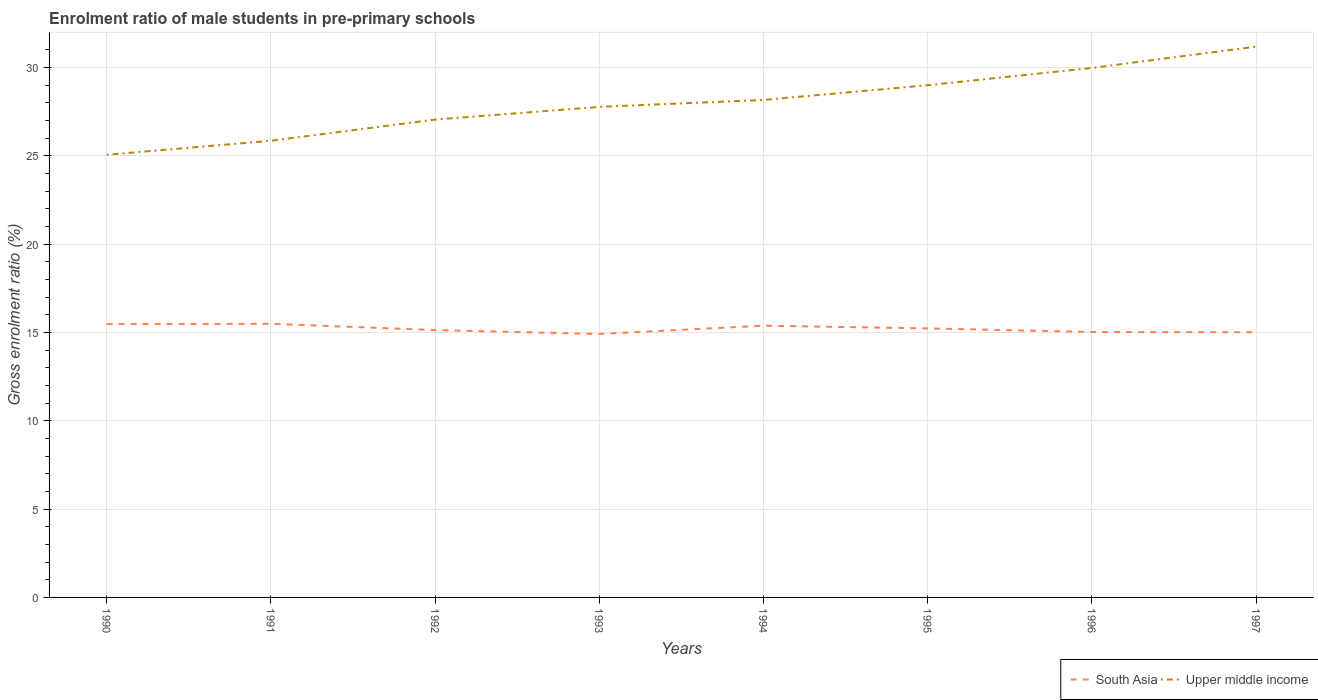How many different coloured lines are there?
Offer a very short reply. 2. Is the number of lines equal to the number of legend labels?
Keep it short and to the point. Yes. Across all years, what is the maximum enrolment ratio of male students in pre-primary schools in South Asia?
Offer a terse response. 14.91. What is the total enrolment ratio of male students in pre-primary schools in South Asia in the graph?
Provide a short and direct response. -0.11. What is the difference between the highest and the second highest enrolment ratio of male students in pre-primary schools in Upper middle income?
Provide a succinct answer. 6.12. How many lines are there?
Offer a terse response. 2. How many years are there in the graph?
Make the answer very short. 8. Does the graph contain any zero values?
Keep it short and to the point. No. Does the graph contain grids?
Keep it short and to the point. Yes. Where does the legend appear in the graph?
Give a very brief answer. Bottom right. How are the legend labels stacked?
Ensure brevity in your answer.  Horizontal. What is the title of the graph?
Make the answer very short. Enrolment ratio of male students in pre-primary schools. Does "Austria" appear as one of the legend labels in the graph?
Your response must be concise. No. What is the label or title of the X-axis?
Provide a short and direct response. Years. What is the Gross enrolment ratio (%) in South Asia in 1990?
Give a very brief answer. 15.47. What is the Gross enrolment ratio (%) in Upper middle income in 1990?
Your response must be concise. 25.06. What is the Gross enrolment ratio (%) of South Asia in 1991?
Your answer should be very brief. 15.49. What is the Gross enrolment ratio (%) in Upper middle income in 1991?
Offer a very short reply. 25.85. What is the Gross enrolment ratio (%) in South Asia in 1992?
Provide a short and direct response. 15.13. What is the Gross enrolment ratio (%) in Upper middle income in 1992?
Offer a very short reply. 27.05. What is the Gross enrolment ratio (%) in South Asia in 1993?
Make the answer very short. 14.91. What is the Gross enrolment ratio (%) in Upper middle income in 1993?
Give a very brief answer. 27.77. What is the Gross enrolment ratio (%) of South Asia in 1994?
Give a very brief answer. 15.38. What is the Gross enrolment ratio (%) of Upper middle income in 1994?
Offer a very short reply. 28.16. What is the Gross enrolment ratio (%) of South Asia in 1995?
Provide a succinct answer. 15.23. What is the Gross enrolment ratio (%) in Upper middle income in 1995?
Your answer should be very brief. 29. What is the Gross enrolment ratio (%) in South Asia in 1996?
Ensure brevity in your answer.  15.03. What is the Gross enrolment ratio (%) in Upper middle income in 1996?
Your answer should be very brief. 29.97. What is the Gross enrolment ratio (%) in South Asia in 1997?
Give a very brief answer. 15.01. What is the Gross enrolment ratio (%) of Upper middle income in 1997?
Offer a very short reply. 31.18. Across all years, what is the maximum Gross enrolment ratio (%) of South Asia?
Your answer should be compact. 15.49. Across all years, what is the maximum Gross enrolment ratio (%) in Upper middle income?
Make the answer very short. 31.18. Across all years, what is the minimum Gross enrolment ratio (%) of South Asia?
Your answer should be compact. 14.91. Across all years, what is the minimum Gross enrolment ratio (%) in Upper middle income?
Provide a succinct answer. 25.06. What is the total Gross enrolment ratio (%) in South Asia in the graph?
Offer a very short reply. 121.66. What is the total Gross enrolment ratio (%) in Upper middle income in the graph?
Offer a terse response. 224.05. What is the difference between the Gross enrolment ratio (%) of South Asia in 1990 and that in 1991?
Give a very brief answer. -0.02. What is the difference between the Gross enrolment ratio (%) of Upper middle income in 1990 and that in 1991?
Provide a succinct answer. -0.79. What is the difference between the Gross enrolment ratio (%) in South Asia in 1990 and that in 1992?
Your answer should be very brief. 0.34. What is the difference between the Gross enrolment ratio (%) of Upper middle income in 1990 and that in 1992?
Give a very brief answer. -1.99. What is the difference between the Gross enrolment ratio (%) of South Asia in 1990 and that in 1993?
Keep it short and to the point. 0.56. What is the difference between the Gross enrolment ratio (%) of Upper middle income in 1990 and that in 1993?
Your answer should be very brief. -2.71. What is the difference between the Gross enrolment ratio (%) in South Asia in 1990 and that in 1994?
Ensure brevity in your answer.  0.09. What is the difference between the Gross enrolment ratio (%) in Upper middle income in 1990 and that in 1994?
Provide a succinct answer. -3.1. What is the difference between the Gross enrolment ratio (%) of South Asia in 1990 and that in 1995?
Your answer should be compact. 0.24. What is the difference between the Gross enrolment ratio (%) in Upper middle income in 1990 and that in 1995?
Give a very brief answer. -3.94. What is the difference between the Gross enrolment ratio (%) in South Asia in 1990 and that in 1996?
Provide a succinct answer. 0.45. What is the difference between the Gross enrolment ratio (%) in Upper middle income in 1990 and that in 1996?
Offer a very short reply. -4.92. What is the difference between the Gross enrolment ratio (%) of South Asia in 1990 and that in 1997?
Give a very brief answer. 0.46. What is the difference between the Gross enrolment ratio (%) in Upper middle income in 1990 and that in 1997?
Give a very brief answer. -6.12. What is the difference between the Gross enrolment ratio (%) in South Asia in 1991 and that in 1992?
Provide a short and direct response. 0.36. What is the difference between the Gross enrolment ratio (%) in Upper middle income in 1991 and that in 1992?
Your answer should be very brief. -1.2. What is the difference between the Gross enrolment ratio (%) in South Asia in 1991 and that in 1993?
Keep it short and to the point. 0.58. What is the difference between the Gross enrolment ratio (%) in Upper middle income in 1991 and that in 1993?
Make the answer very short. -1.92. What is the difference between the Gross enrolment ratio (%) in South Asia in 1991 and that in 1994?
Provide a short and direct response. 0.11. What is the difference between the Gross enrolment ratio (%) of Upper middle income in 1991 and that in 1994?
Make the answer very short. -2.31. What is the difference between the Gross enrolment ratio (%) of South Asia in 1991 and that in 1995?
Your answer should be compact. 0.26. What is the difference between the Gross enrolment ratio (%) in Upper middle income in 1991 and that in 1995?
Provide a short and direct response. -3.15. What is the difference between the Gross enrolment ratio (%) of South Asia in 1991 and that in 1996?
Your answer should be compact. 0.47. What is the difference between the Gross enrolment ratio (%) of Upper middle income in 1991 and that in 1996?
Give a very brief answer. -4.12. What is the difference between the Gross enrolment ratio (%) of South Asia in 1991 and that in 1997?
Your response must be concise. 0.48. What is the difference between the Gross enrolment ratio (%) of Upper middle income in 1991 and that in 1997?
Keep it short and to the point. -5.33. What is the difference between the Gross enrolment ratio (%) of South Asia in 1992 and that in 1993?
Provide a succinct answer. 0.22. What is the difference between the Gross enrolment ratio (%) in Upper middle income in 1992 and that in 1993?
Give a very brief answer. -0.72. What is the difference between the Gross enrolment ratio (%) of South Asia in 1992 and that in 1994?
Offer a terse response. -0.25. What is the difference between the Gross enrolment ratio (%) of Upper middle income in 1992 and that in 1994?
Provide a succinct answer. -1.11. What is the difference between the Gross enrolment ratio (%) in South Asia in 1992 and that in 1995?
Make the answer very short. -0.09. What is the difference between the Gross enrolment ratio (%) of Upper middle income in 1992 and that in 1995?
Make the answer very short. -1.95. What is the difference between the Gross enrolment ratio (%) in South Asia in 1992 and that in 1996?
Provide a succinct answer. 0.11. What is the difference between the Gross enrolment ratio (%) in Upper middle income in 1992 and that in 1996?
Ensure brevity in your answer.  -2.92. What is the difference between the Gross enrolment ratio (%) in South Asia in 1992 and that in 1997?
Give a very brief answer. 0.12. What is the difference between the Gross enrolment ratio (%) in Upper middle income in 1992 and that in 1997?
Your response must be concise. -4.13. What is the difference between the Gross enrolment ratio (%) of South Asia in 1993 and that in 1994?
Your answer should be very brief. -0.47. What is the difference between the Gross enrolment ratio (%) of Upper middle income in 1993 and that in 1994?
Keep it short and to the point. -0.39. What is the difference between the Gross enrolment ratio (%) of South Asia in 1993 and that in 1995?
Your answer should be very brief. -0.32. What is the difference between the Gross enrolment ratio (%) in Upper middle income in 1993 and that in 1995?
Your answer should be compact. -1.23. What is the difference between the Gross enrolment ratio (%) in South Asia in 1993 and that in 1996?
Keep it short and to the point. -0.11. What is the difference between the Gross enrolment ratio (%) of Upper middle income in 1993 and that in 1996?
Your answer should be very brief. -2.2. What is the difference between the Gross enrolment ratio (%) in South Asia in 1993 and that in 1997?
Provide a succinct answer. -0.1. What is the difference between the Gross enrolment ratio (%) of Upper middle income in 1993 and that in 1997?
Offer a terse response. -3.41. What is the difference between the Gross enrolment ratio (%) of South Asia in 1994 and that in 1995?
Provide a short and direct response. 0.15. What is the difference between the Gross enrolment ratio (%) in Upper middle income in 1994 and that in 1995?
Provide a succinct answer. -0.83. What is the difference between the Gross enrolment ratio (%) in South Asia in 1994 and that in 1996?
Make the answer very short. 0.36. What is the difference between the Gross enrolment ratio (%) in Upper middle income in 1994 and that in 1996?
Your answer should be very brief. -1.81. What is the difference between the Gross enrolment ratio (%) of South Asia in 1994 and that in 1997?
Ensure brevity in your answer.  0.37. What is the difference between the Gross enrolment ratio (%) in Upper middle income in 1994 and that in 1997?
Provide a succinct answer. -3.02. What is the difference between the Gross enrolment ratio (%) in South Asia in 1995 and that in 1996?
Your response must be concise. 0.2. What is the difference between the Gross enrolment ratio (%) in Upper middle income in 1995 and that in 1996?
Your response must be concise. -0.98. What is the difference between the Gross enrolment ratio (%) in South Asia in 1995 and that in 1997?
Offer a very short reply. 0.22. What is the difference between the Gross enrolment ratio (%) in Upper middle income in 1995 and that in 1997?
Ensure brevity in your answer.  -2.18. What is the difference between the Gross enrolment ratio (%) of South Asia in 1996 and that in 1997?
Give a very brief answer. 0.01. What is the difference between the Gross enrolment ratio (%) of Upper middle income in 1996 and that in 1997?
Your response must be concise. -1.21. What is the difference between the Gross enrolment ratio (%) in South Asia in 1990 and the Gross enrolment ratio (%) in Upper middle income in 1991?
Keep it short and to the point. -10.38. What is the difference between the Gross enrolment ratio (%) of South Asia in 1990 and the Gross enrolment ratio (%) of Upper middle income in 1992?
Provide a short and direct response. -11.58. What is the difference between the Gross enrolment ratio (%) in South Asia in 1990 and the Gross enrolment ratio (%) in Upper middle income in 1993?
Give a very brief answer. -12.3. What is the difference between the Gross enrolment ratio (%) in South Asia in 1990 and the Gross enrolment ratio (%) in Upper middle income in 1994?
Your answer should be compact. -12.69. What is the difference between the Gross enrolment ratio (%) of South Asia in 1990 and the Gross enrolment ratio (%) of Upper middle income in 1995?
Provide a short and direct response. -13.53. What is the difference between the Gross enrolment ratio (%) of South Asia in 1990 and the Gross enrolment ratio (%) of Upper middle income in 1996?
Give a very brief answer. -14.5. What is the difference between the Gross enrolment ratio (%) of South Asia in 1990 and the Gross enrolment ratio (%) of Upper middle income in 1997?
Ensure brevity in your answer.  -15.71. What is the difference between the Gross enrolment ratio (%) of South Asia in 1991 and the Gross enrolment ratio (%) of Upper middle income in 1992?
Your answer should be very brief. -11.56. What is the difference between the Gross enrolment ratio (%) in South Asia in 1991 and the Gross enrolment ratio (%) in Upper middle income in 1993?
Provide a succinct answer. -12.28. What is the difference between the Gross enrolment ratio (%) of South Asia in 1991 and the Gross enrolment ratio (%) of Upper middle income in 1994?
Your answer should be compact. -12.67. What is the difference between the Gross enrolment ratio (%) of South Asia in 1991 and the Gross enrolment ratio (%) of Upper middle income in 1995?
Offer a terse response. -13.51. What is the difference between the Gross enrolment ratio (%) of South Asia in 1991 and the Gross enrolment ratio (%) of Upper middle income in 1996?
Your response must be concise. -14.48. What is the difference between the Gross enrolment ratio (%) of South Asia in 1991 and the Gross enrolment ratio (%) of Upper middle income in 1997?
Make the answer very short. -15.69. What is the difference between the Gross enrolment ratio (%) of South Asia in 1992 and the Gross enrolment ratio (%) of Upper middle income in 1993?
Your response must be concise. -12.64. What is the difference between the Gross enrolment ratio (%) of South Asia in 1992 and the Gross enrolment ratio (%) of Upper middle income in 1994?
Your answer should be compact. -13.03. What is the difference between the Gross enrolment ratio (%) in South Asia in 1992 and the Gross enrolment ratio (%) in Upper middle income in 1995?
Provide a short and direct response. -13.86. What is the difference between the Gross enrolment ratio (%) in South Asia in 1992 and the Gross enrolment ratio (%) in Upper middle income in 1996?
Make the answer very short. -14.84. What is the difference between the Gross enrolment ratio (%) of South Asia in 1992 and the Gross enrolment ratio (%) of Upper middle income in 1997?
Your answer should be compact. -16.05. What is the difference between the Gross enrolment ratio (%) in South Asia in 1993 and the Gross enrolment ratio (%) in Upper middle income in 1994?
Your answer should be very brief. -13.25. What is the difference between the Gross enrolment ratio (%) in South Asia in 1993 and the Gross enrolment ratio (%) in Upper middle income in 1995?
Keep it short and to the point. -14.08. What is the difference between the Gross enrolment ratio (%) of South Asia in 1993 and the Gross enrolment ratio (%) of Upper middle income in 1996?
Your response must be concise. -15.06. What is the difference between the Gross enrolment ratio (%) of South Asia in 1993 and the Gross enrolment ratio (%) of Upper middle income in 1997?
Offer a very short reply. -16.27. What is the difference between the Gross enrolment ratio (%) in South Asia in 1994 and the Gross enrolment ratio (%) in Upper middle income in 1995?
Offer a very short reply. -13.61. What is the difference between the Gross enrolment ratio (%) of South Asia in 1994 and the Gross enrolment ratio (%) of Upper middle income in 1996?
Offer a very short reply. -14.59. What is the difference between the Gross enrolment ratio (%) of South Asia in 1994 and the Gross enrolment ratio (%) of Upper middle income in 1997?
Offer a terse response. -15.8. What is the difference between the Gross enrolment ratio (%) in South Asia in 1995 and the Gross enrolment ratio (%) in Upper middle income in 1996?
Your response must be concise. -14.74. What is the difference between the Gross enrolment ratio (%) of South Asia in 1995 and the Gross enrolment ratio (%) of Upper middle income in 1997?
Provide a short and direct response. -15.95. What is the difference between the Gross enrolment ratio (%) in South Asia in 1996 and the Gross enrolment ratio (%) in Upper middle income in 1997?
Offer a terse response. -16.16. What is the average Gross enrolment ratio (%) of South Asia per year?
Provide a short and direct response. 15.21. What is the average Gross enrolment ratio (%) of Upper middle income per year?
Provide a short and direct response. 28.01. In the year 1990, what is the difference between the Gross enrolment ratio (%) in South Asia and Gross enrolment ratio (%) in Upper middle income?
Keep it short and to the point. -9.59. In the year 1991, what is the difference between the Gross enrolment ratio (%) of South Asia and Gross enrolment ratio (%) of Upper middle income?
Provide a succinct answer. -10.36. In the year 1992, what is the difference between the Gross enrolment ratio (%) in South Asia and Gross enrolment ratio (%) in Upper middle income?
Keep it short and to the point. -11.92. In the year 1993, what is the difference between the Gross enrolment ratio (%) of South Asia and Gross enrolment ratio (%) of Upper middle income?
Your answer should be compact. -12.86. In the year 1994, what is the difference between the Gross enrolment ratio (%) of South Asia and Gross enrolment ratio (%) of Upper middle income?
Your answer should be compact. -12.78. In the year 1995, what is the difference between the Gross enrolment ratio (%) of South Asia and Gross enrolment ratio (%) of Upper middle income?
Give a very brief answer. -13.77. In the year 1996, what is the difference between the Gross enrolment ratio (%) in South Asia and Gross enrolment ratio (%) in Upper middle income?
Keep it short and to the point. -14.95. In the year 1997, what is the difference between the Gross enrolment ratio (%) of South Asia and Gross enrolment ratio (%) of Upper middle income?
Your answer should be compact. -16.17. What is the ratio of the Gross enrolment ratio (%) of Upper middle income in 1990 to that in 1991?
Offer a terse response. 0.97. What is the ratio of the Gross enrolment ratio (%) in South Asia in 1990 to that in 1992?
Your response must be concise. 1.02. What is the ratio of the Gross enrolment ratio (%) in Upper middle income in 1990 to that in 1992?
Provide a succinct answer. 0.93. What is the ratio of the Gross enrolment ratio (%) of South Asia in 1990 to that in 1993?
Your answer should be compact. 1.04. What is the ratio of the Gross enrolment ratio (%) of Upper middle income in 1990 to that in 1993?
Your response must be concise. 0.9. What is the ratio of the Gross enrolment ratio (%) in South Asia in 1990 to that in 1994?
Provide a short and direct response. 1.01. What is the ratio of the Gross enrolment ratio (%) in Upper middle income in 1990 to that in 1994?
Keep it short and to the point. 0.89. What is the ratio of the Gross enrolment ratio (%) of South Asia in 1990 to that in 1995?
Give a very brief answer. 1.02. What is the ratio of the Gross enrolment ratio (%) in Upper middle income in 1990 to that in 1995?
Offer a terse response. 0.86. What is the ratio of the Gross enrolment ratio (%) in South Asia in 1990 to that in 1996?
Give a very brief answer. 1.03. What is the ratio of the Gross enrolment ratio (%) of Upper middle income in 1990 to that in 1996?
Your answer should be very brief. 0.84. What is the ratio of the Gross enrolment ratio (%) in South Asia in 1990 to that in 1997?
Offer a very short reply. 1.03. What is the ratio of the Gross enrolment ratio (%) in Upper middle income in 1990 to that in 1997?
Make the answer very short. 0.8. What is the ratio of the Gross enrolment ratio (%) in South Asia in 1991 to that in 1992?
Make the answer very short. 1.02. What is the ratio of the Gross enrolment ratio (%) in Upper middle income in 1991 to that in 1992?
Provide a short and direct response. 0.96. What is the ratio of the Gross enrolment ratio (%) in South Asia in 1991 to that in 1993?
Make the answer very short. 1.04. What is the ratio of the Gross enrolment ratio (%) of Upper middle income in 1991 to that in 1993?
Provide a succinct answer. 0.93. What is the ratio of the Gross enrolment ratio (%) of Upper middle income in 1991 to that in 1994?
Keep it short and to the point. 0.92. What is the ratio of the Gross enrolment ratio (%) of South Asia in 1991 to that in 1995?
Ensure brevity in your answer.  1.02. What is the ratio of the Gross enrolment ratio (%) of Upper middle income in 1991 to that in 1995?
Keep it short and to the point. 0.89. What is the ratio of the Gross enrolment ratio (%) of South Asia in 1991 to that in 1996?
Your answer should be compact. 1.03. What is the ratio of the Gross enrolment ratio (%) of Upper middle income in 1991 to that in 1996?
Keep it short and to the point. 0.86. What is the ratio of the Gross enrolment ratio (%) of South Asia in 1991 to that in 1997?
Make the answer very short. 1.03. What is the ratio of the Gross enrolment ratio (%) in Upper middle income in 1991 to that in 1997?
Your response must be concise. 0.83. What is the ratio of the Gross enrolment ratio (%) of South Asia in 1992 to that in 1993?
Give a very brief answer. 1.01. What is the ratio of the Gross enrolment ratio (%) in Upper middle income in 1992 to that in 1993?
Offer a very short reply. 0.97. What is the ratio of the Gross enrolment ratio (%) of South Asia in 1992 to that in 1994?
Your answer should be very brief. 0.98. What is the ratio of the Gross enrolment ratio (%) of Upper middle income in 1992 to that in 1994?
Your response must be concise. 0.96. What is the ratio of the Gross enrolment ratio (%) in South Asia in 1992 to that in 1995?
Your answer should be compact. 0.99. What is the ratio of the Gross enrolment ratio (%) of Upper middle income in 1992 to that in 1995?
Provide a short and direct response. 0.93. What is the ratio of the Gross enrolment ratio (%) in South Asia in 1992 to that in 1996?
Provide a short and direct response. 1.01. What is the ratio of the Gross enrolment ratio (%) in Upper middle income in 1992 to that in 1996?
Your answer should be very brief. 0.9. What is the ratio of the Gross enrolment ratio (%) of South Asia in 1992 to that in 1997?
Provide a succinct answer. 1.01. What is the ratio of the Gross enrolment ratio (%) of Upper middle income in 1992 to that in 1997?
Your answer should be compact. 0.87. What is the ratio of the Gross enrolment ratio (%) of South Asia in 1993 to that in 1994?
Your response must be concise. 0.97. What is the ratio of the Gross enrolment ratio (%) in Upper middle income in 1993 to that in 1994?
Offer a terse response. 0.99. What is the ratio of the Gross enrolment ratio (%) of South Asia in 1993 to that in 1995?
Offer a terse response. 0.98. What is the ratio of the Gross enrolment ratio (%) in Upper middle income in 1993 to that in 1995?
Provide a short and direct response. 0.96. What is the ratio of the Gross enrolment ratio (%) in Upper middle income in 1993 to that in 1996?
Provide a short and direct response. 0.93. What is the ratio of the Gross enrolment ratio (%) in Upper middle income in 1993 to that in 1997?
Your response must be concise. 0.89. What is the ratio of the Gross enrolment ratio (%) in South Asia in 1994 to that in 1995?
Provide a short and direct response. 1.01. What is the ratio of the Gross enrolment ratio (%) of Upper middle income in 1994 to that in 1995?
Provide a succinct answer. 0.97. What is the ratio of the Gross enrolment ratio (%) in South Asia in 1994 to that in 1996?
Offer a terse response. 1.02. What is the ratio of the Gross enrolment ratio (%) of Upper middle income in 1994 to that in 1996?
Make the answer very short. 0.94. What is the ratio of the Gross enrolment ratio (%) in South Asia in 1994 to that in 1997?
Offer a terse response. 1.02. What is the ratio of the Gross enrolment ratio (%) of Upper middle income in 1994 to that in 1997?
Your answer should be compact. 0.9. What is the ratio of the Gross enrolment ratio (%) of South Asia in 1995 to that in 1996?
Ensure brevity in your answer.  1.01. What is the ratio of the Gross enrolment ratio (%) in Upper middle income in 1995 to that in 1996?
Your answer should be compact. 0.97. What is the ratio of the Gross enrolment ratio (%) of South Asia in 1995 to that in 1997?
Your answer should be very brief. 1.01. What is the ratio of the Gross enrolment ratio (%) in Upper middle income in 1995 to that in 1997?
Offer a terse response. 0.93. What is the ratio of the Gross enrolment ratio (%) in Upper middle income in 1996 to that in 1997?
Your response must be concise. 0.96. What is the difference between the highest and the second highest Gross enrolment ratio (%) of South Asia?
Your answer should be compact. 0.02. What is the difference between the highest and the second highest Gross enrolment ratio (%) in Upper middle income?
Ensure brevity in your answer.  1.21. What is the difference between the highest and the lowest Gross enrolment ratio (%) in South Asia?
Offer a terse response. 0.58. What is the difference between the highest and the lowest Gross enrolment ratio (%) in Upper middle income?
Provide a short and direct response. 6.12. 